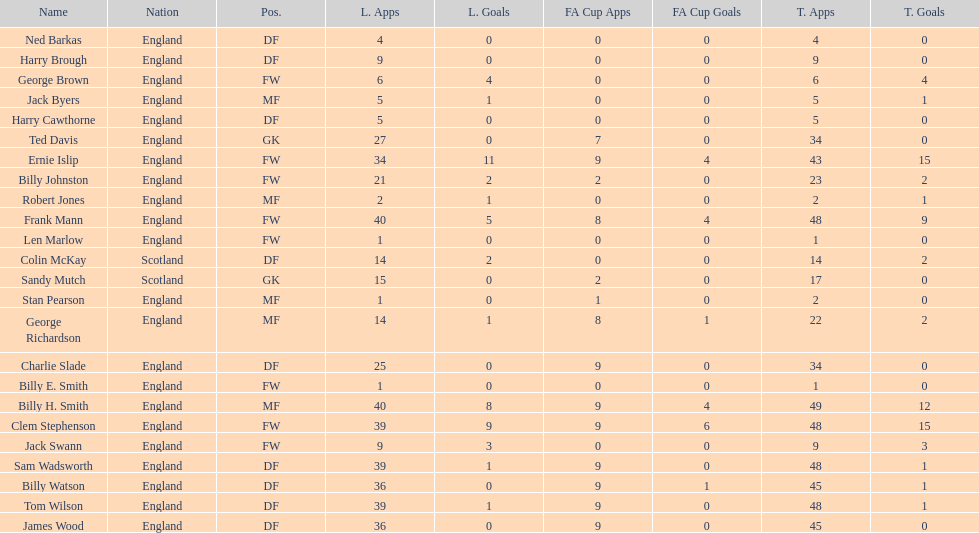What is the average number of scotland's total apps? 15.5. 